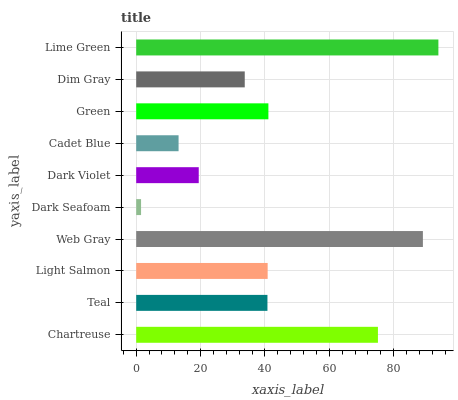Is Dark Seafoam the minimum?
Answer yes or no. Yes. Is Lime Green the maximum?
Answer yes or no. Yes. Is Teal the minimum?
Answer yes or no. No. Is Teal the maximum?
Answer yes or no. No. Is Chartreuse greater than Teal?
Answer yes or no. Yes. Is Teal less than Chartreuse?
Answer yes or no. Yes. Is Teal greater than Chartreuse?
Answer yes or no. No. Is Chartreuse less than Teal?
Answer yes or no. No. Is Light Salmon the high median?
Answer yes or no. Yes. Is Teal the low median?
Answer yes or no. Yes. Is Lime Green the high median?
Answer yes or no. No. Is Cadet Blue the low median?
Answer yes or no. No. 